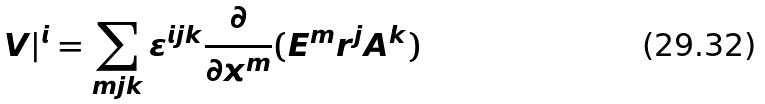<formula> <loc_0><loc_0><loc_500><loc_500>V | ^ { i } = \sum _ { m j k } \varepsilon ^ { i j k } \frac { \partial } { \partial x ^ { m } } ( E ^ { m } r ^ { j } A ^ { k } )</formula> 